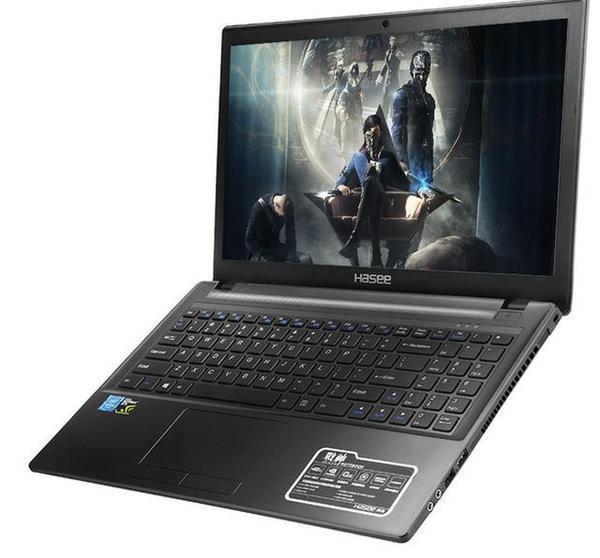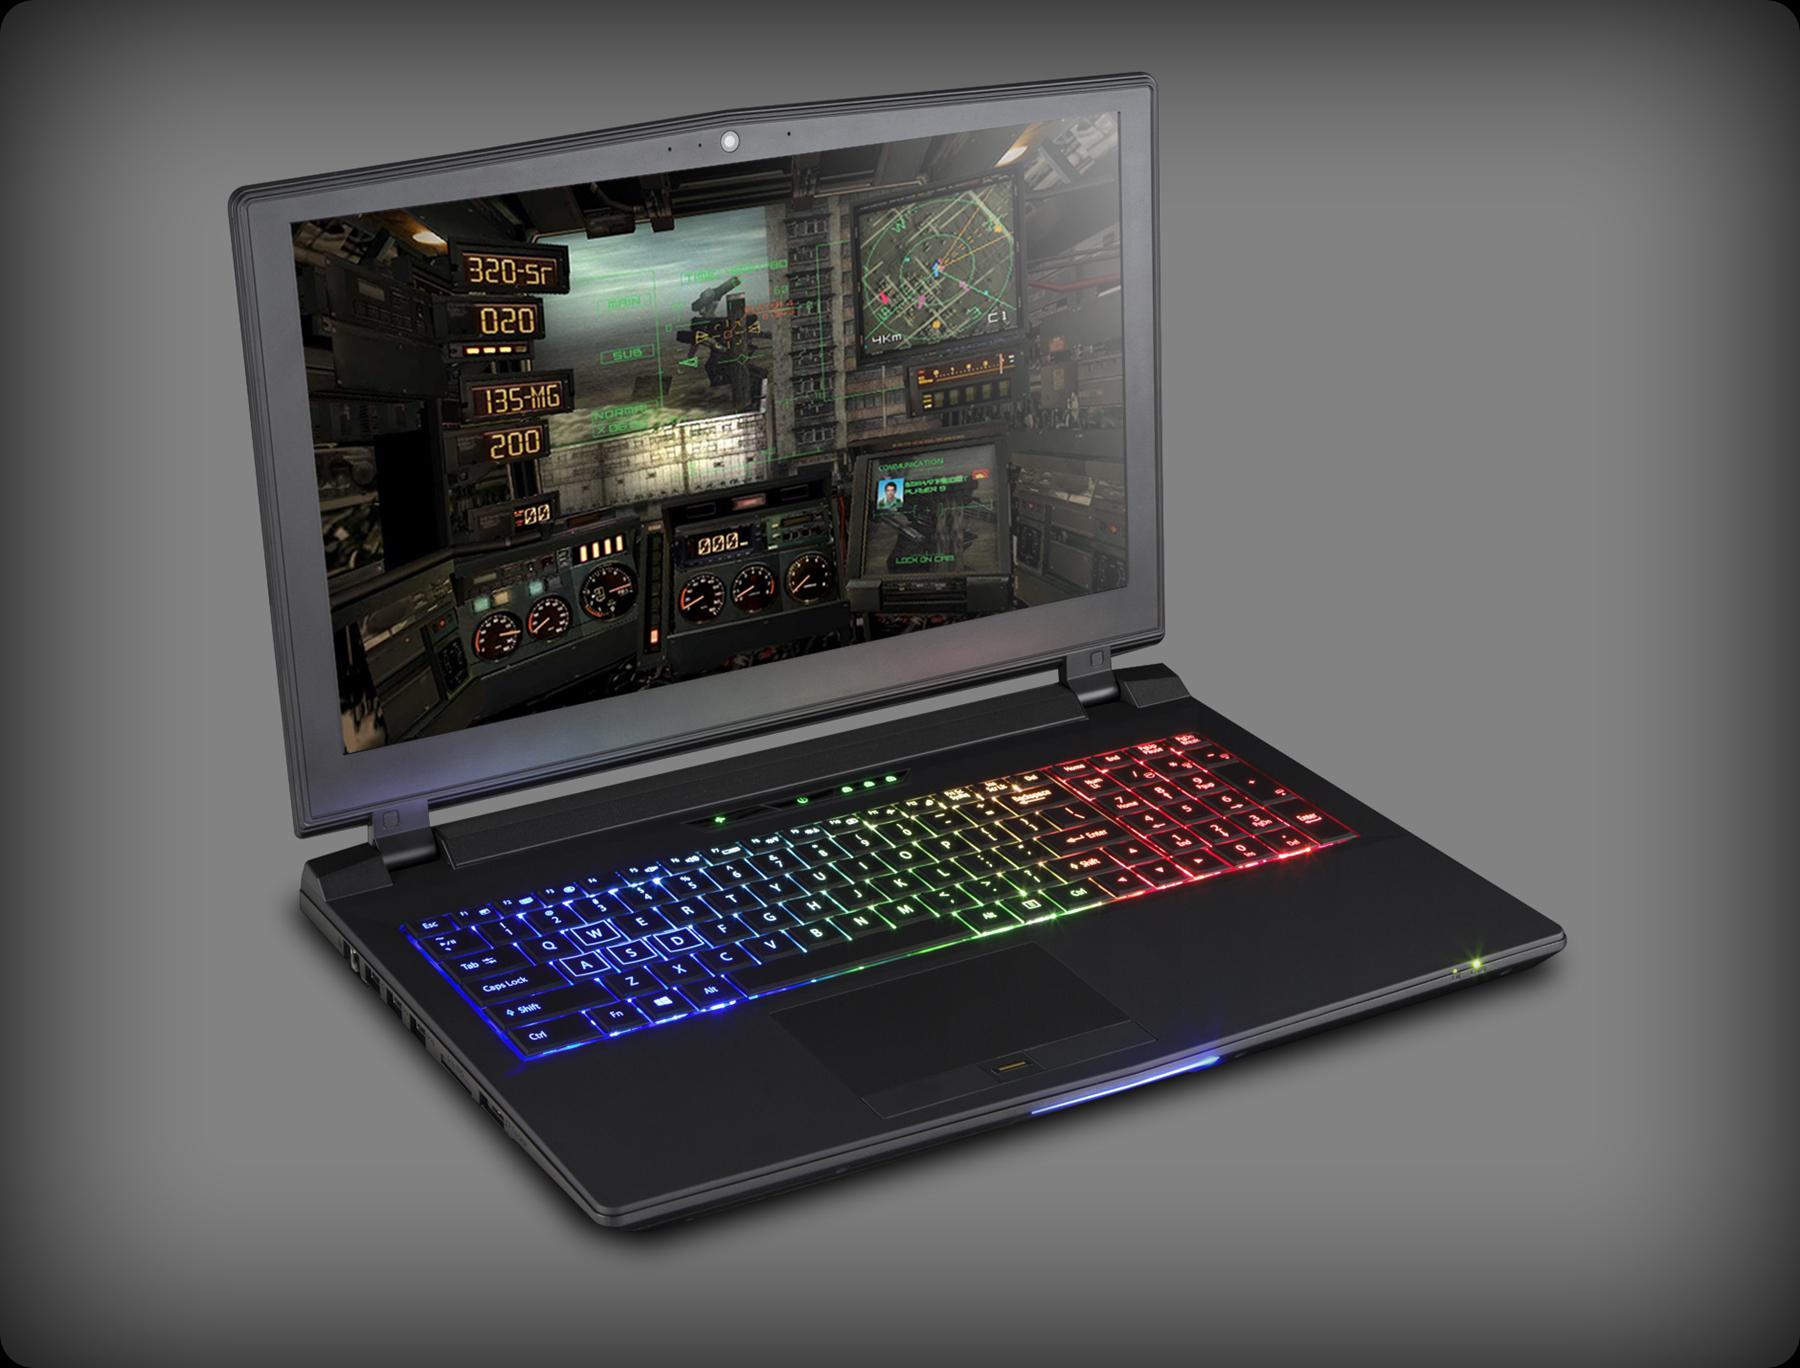The first image is the image on the left, the second image is the image on the right. Given the left and right images, does the statement "there is a laptop with rainbow colored lit up kets and a lit up light in front of the laptops base" hold true? Answer yes or no. Yes. The first image is the image on the left, the second image is the image on the right. Analyze the images presented: Is the assertion "One image shows an open laptop viewed head-on and screen-first, and the other image shows an open laptop with a black screen displayed at an angle." valid? Answer yes or no. No. 